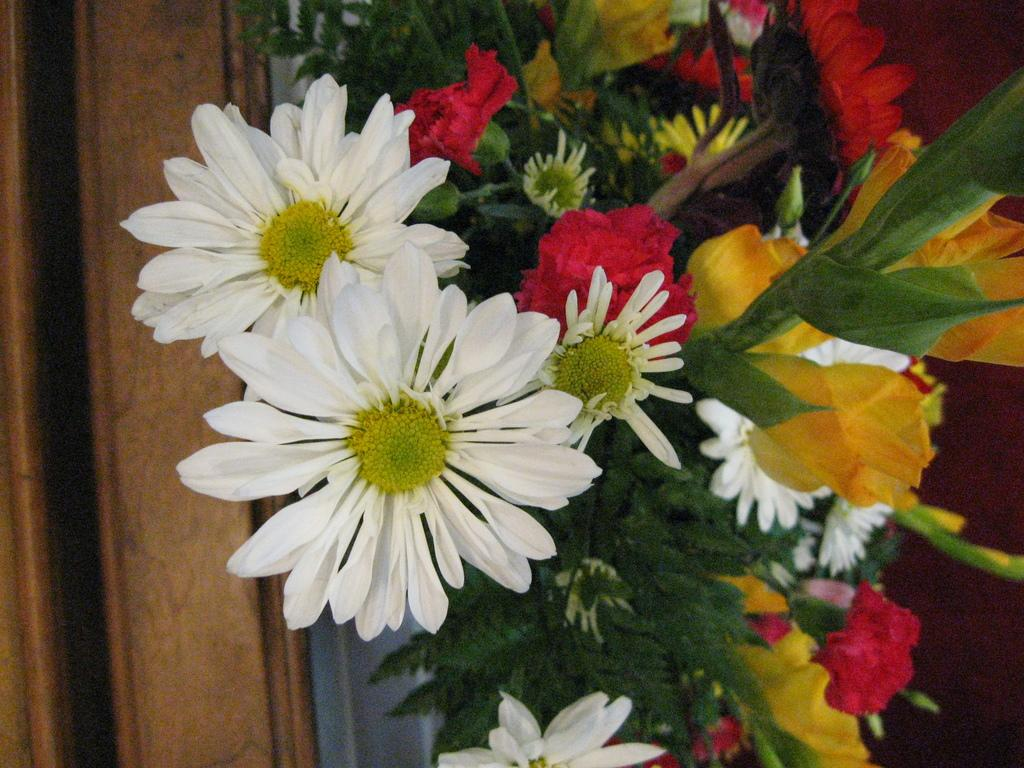What colors of flowers can be seen in the image? There are white, red, and yellow color flowers in the image. What other parts of the flowers are visible besides the petals? The flowers have leaves. What material can be seen on the left side of the image? There is wood visible on the left side of the image. What type of blade is being used to cut the flowers in the image? There is no blade present in the image, and the flowers are not being cut. 